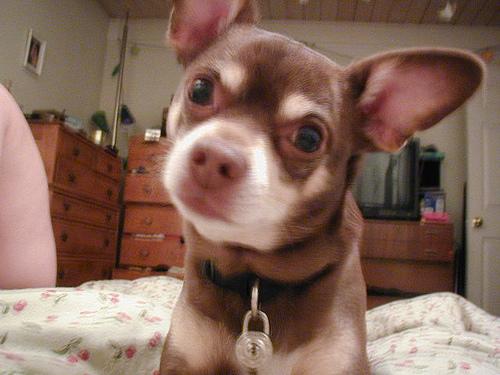What charm or pendant is the dog wearing on its collar?
Be succinct. Lock. Does the dog appear happy?
Answer briefly. Yes. What breed of dog is this?
Short answer required. Chihuahua. What color is the collar?
Answer briefly. Black. 